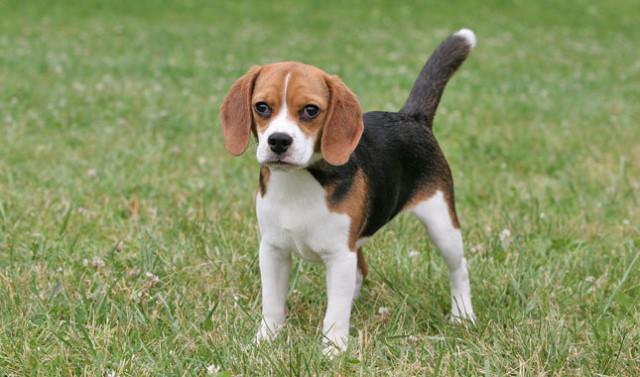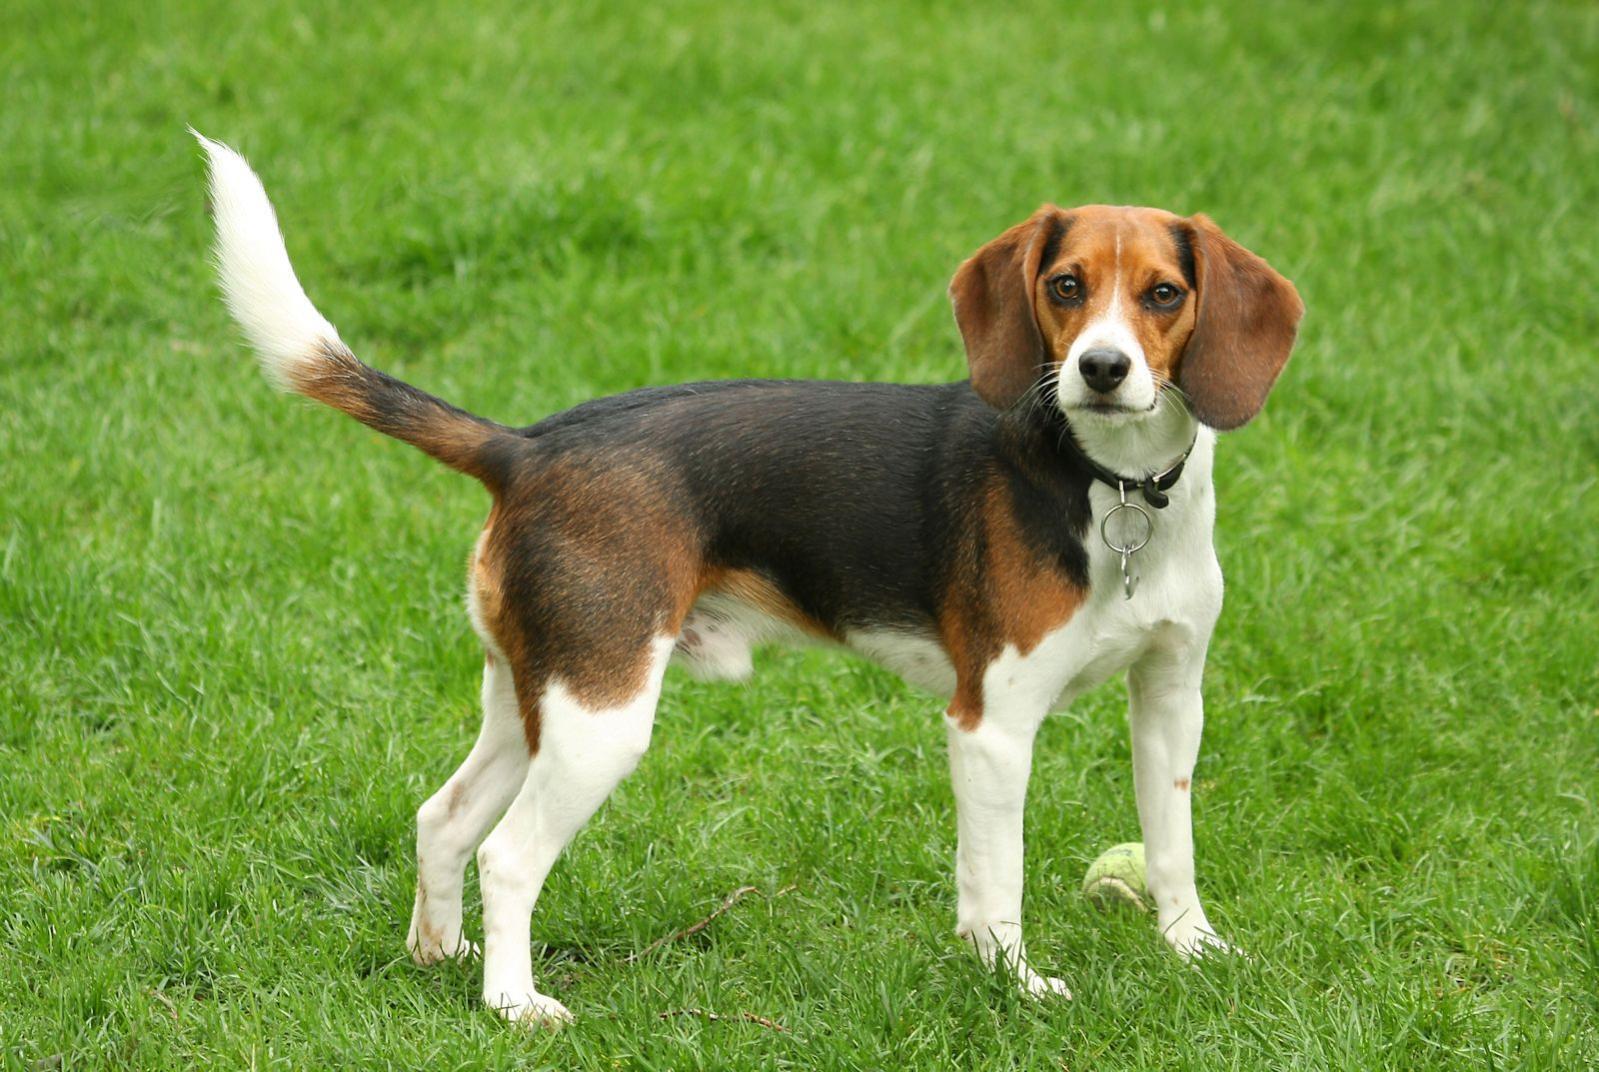The first image is the image on the left, the second image is the image on the right. Examine the images to the left and right. Is the description "In the right image the dog is facing right, and in the left image the dog is facing left." accurate? Answer yes or no. Yes. 